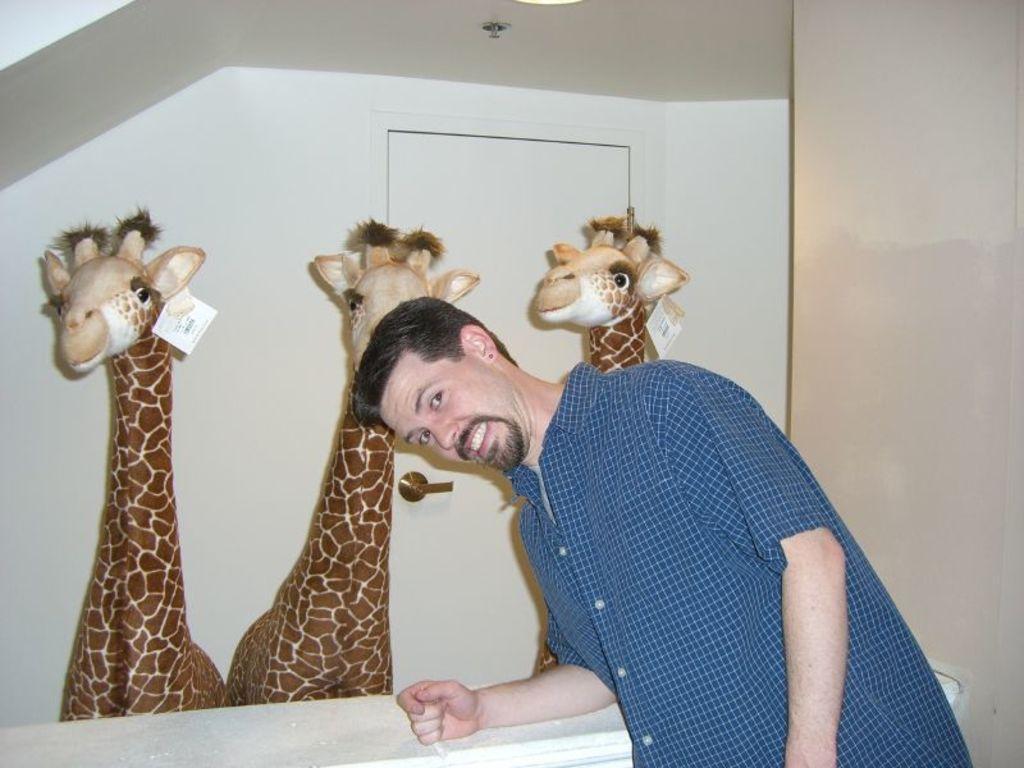In one or two sentences, can you explain what this image depicts? In this image in the front there is a person standing and smiling. In the center there are toys. In the background there is a wall and there is a door. 